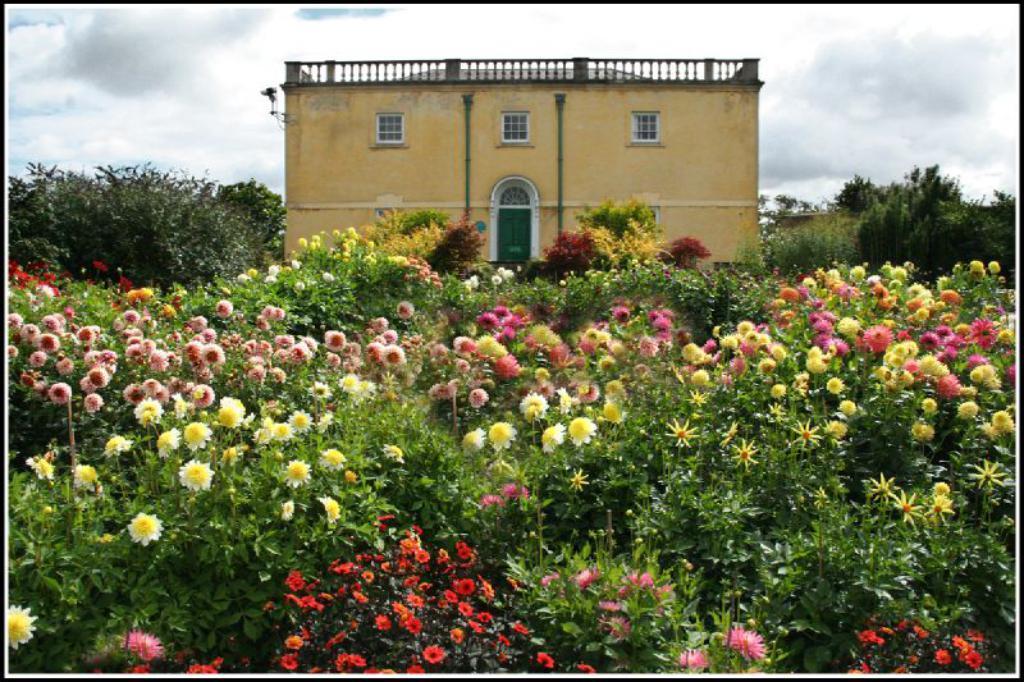Could you give a brief overview of what you see in this image? These are the beautiful flower plants in the front side of an image and in the back side. There is a house which is in an yellow color. 